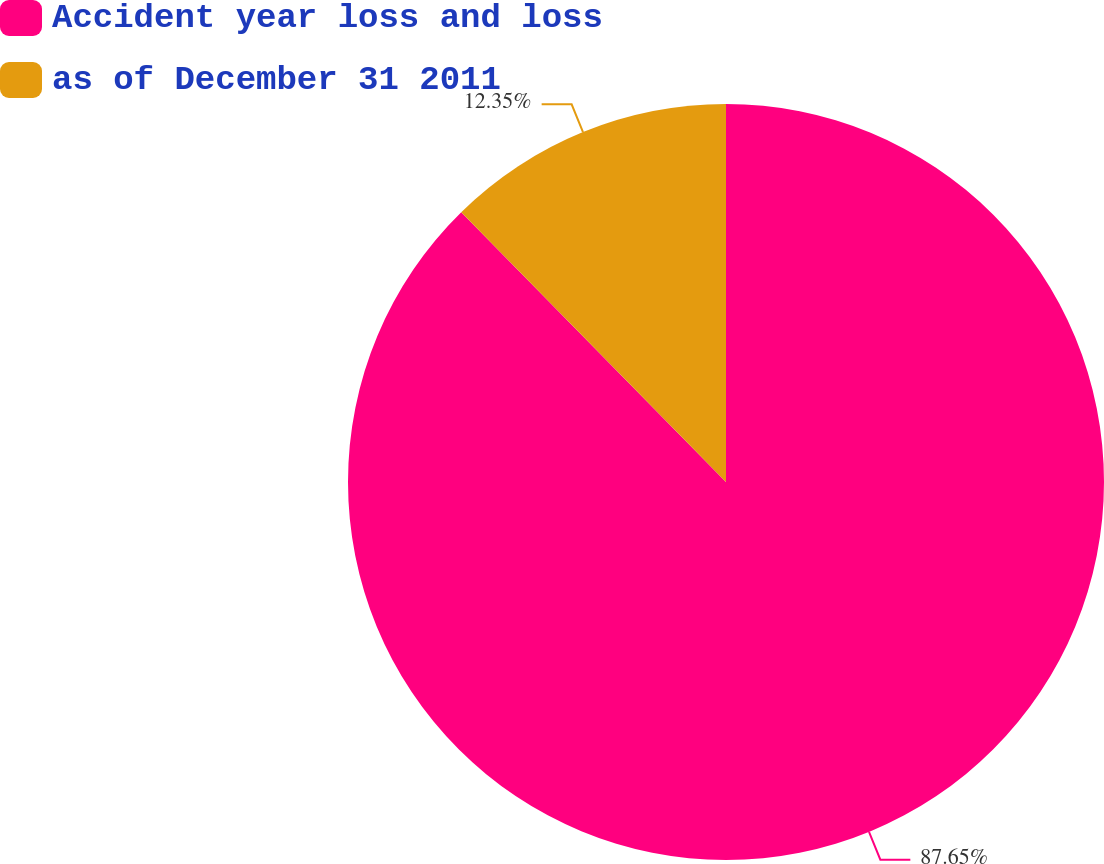<chart> <loc_0><loc_0><loc_500><loc_500><pie_chart><fcel>Accident year loss and loss<fcel>as of December 31 2011<nl><fcel>87.65%<fcel>12.35%<nl></chart> 